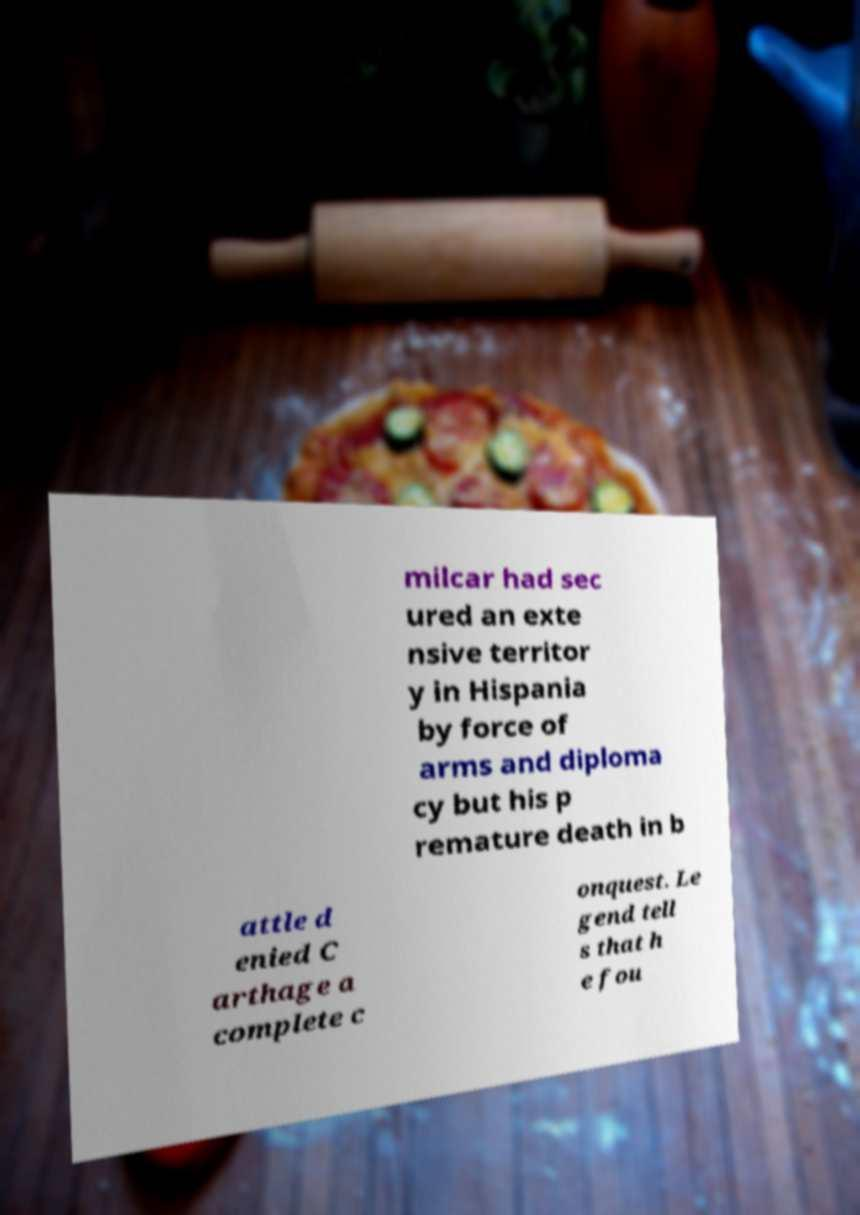There's text embedded in this image that I need extracted. Can you transcribe it verbatim? milcar had sec ured an exte nsive territor y in Hispania by force of arms and diploma cy but his p remature death in b attle d enied C arthage a complete c onquest. Le gend tell s that h e fou 